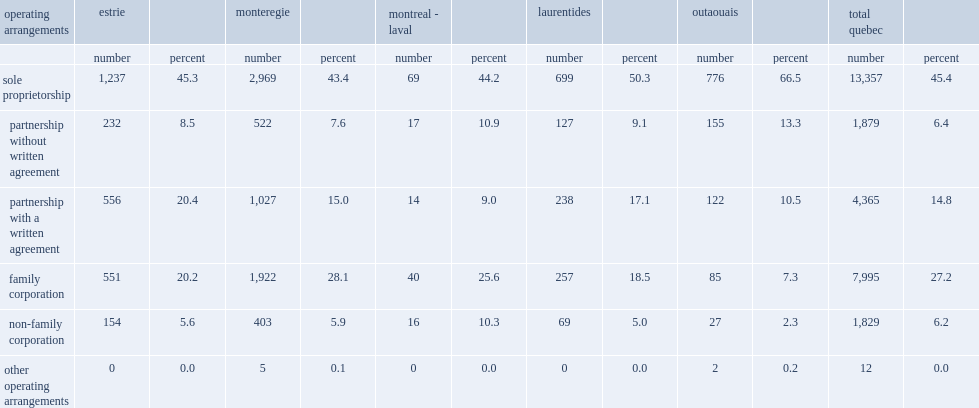List all the regions that had more sole proprietorships compared than in the entrie province(45.4%). Laurentides outaouais. 